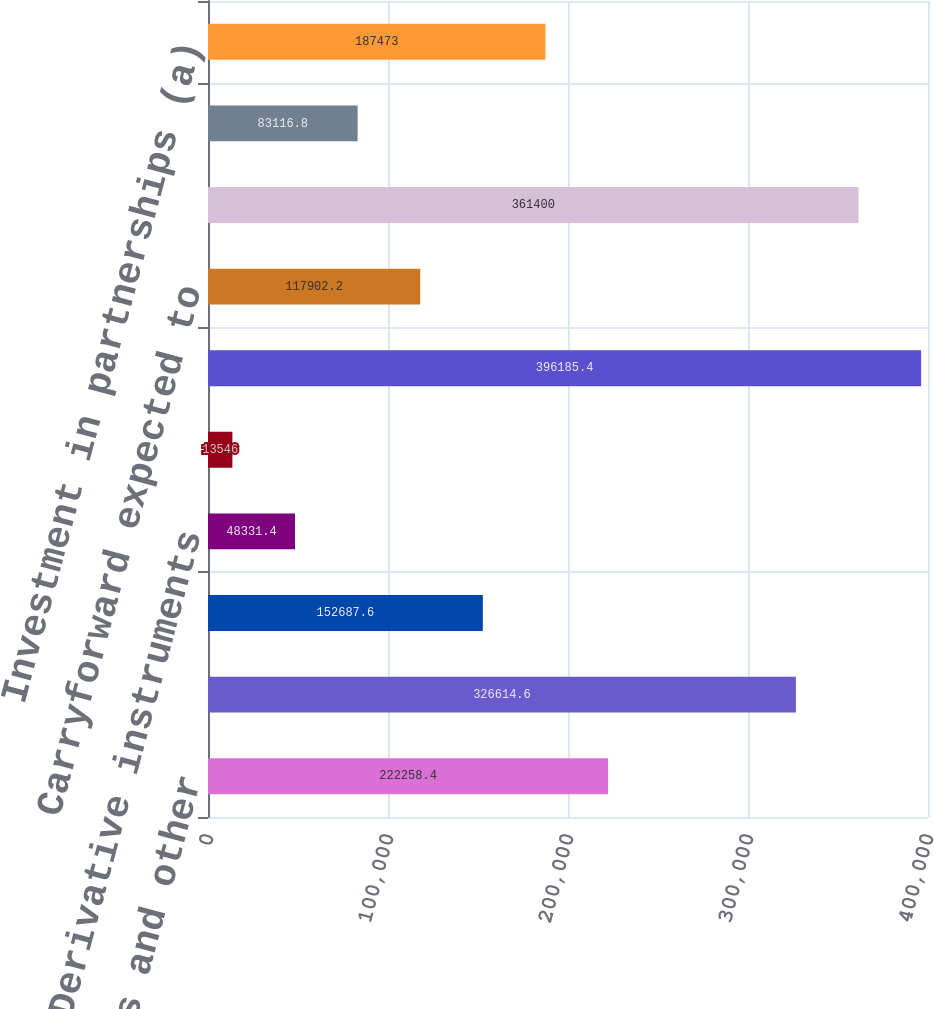Convert chart to OTSL. <chart><loc_0><loc_0><loc_500><loc_500><bar_chart><fcel>Employee benefits and other<fcel>Federal net operating loss<fcel>State net operating loss and<fcel>Derivative instruments<fcel>Other<fcel>Total deferred tax assets<fcel>Carryforward expected to<fcel>Net deferred tax assets<fcel>Excess of tax over book<fcel>Investment in partnerships (a)<nl><fcel>222258<fcel>326615<fcel>152688<fcel>48331.4<fcel>13546<fcel>396185<fcel>117902<fcel>361400<fcel>83116.8<fcel>187473<nl></chart> 